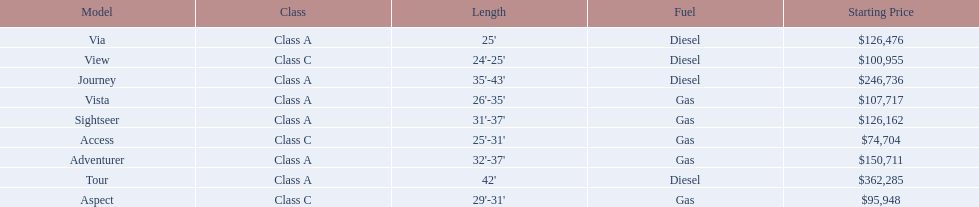Which of the models in the table use diesel fuel? Tour, Journey, Via, View. Of these models, which are class a? Tour, Journey, Via. Which of them are greater than 35' in length? Tour, Journey. Which of the two models is more expensive? Tour. 